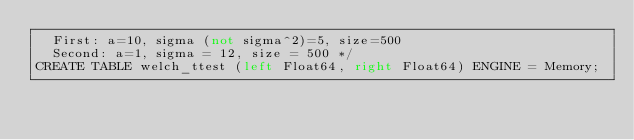Convert code to text. <code><loc_0><loc_0><loc_500><loc_500><_SQL_>  First: a=10, sigma (not sigma^2)=5, size=500
  Second: a=1, sigma = 12, size = 500 */
CREATE TABLE welch_ttest (left Float64, right Float64) ENGINE = Memory;</code> 